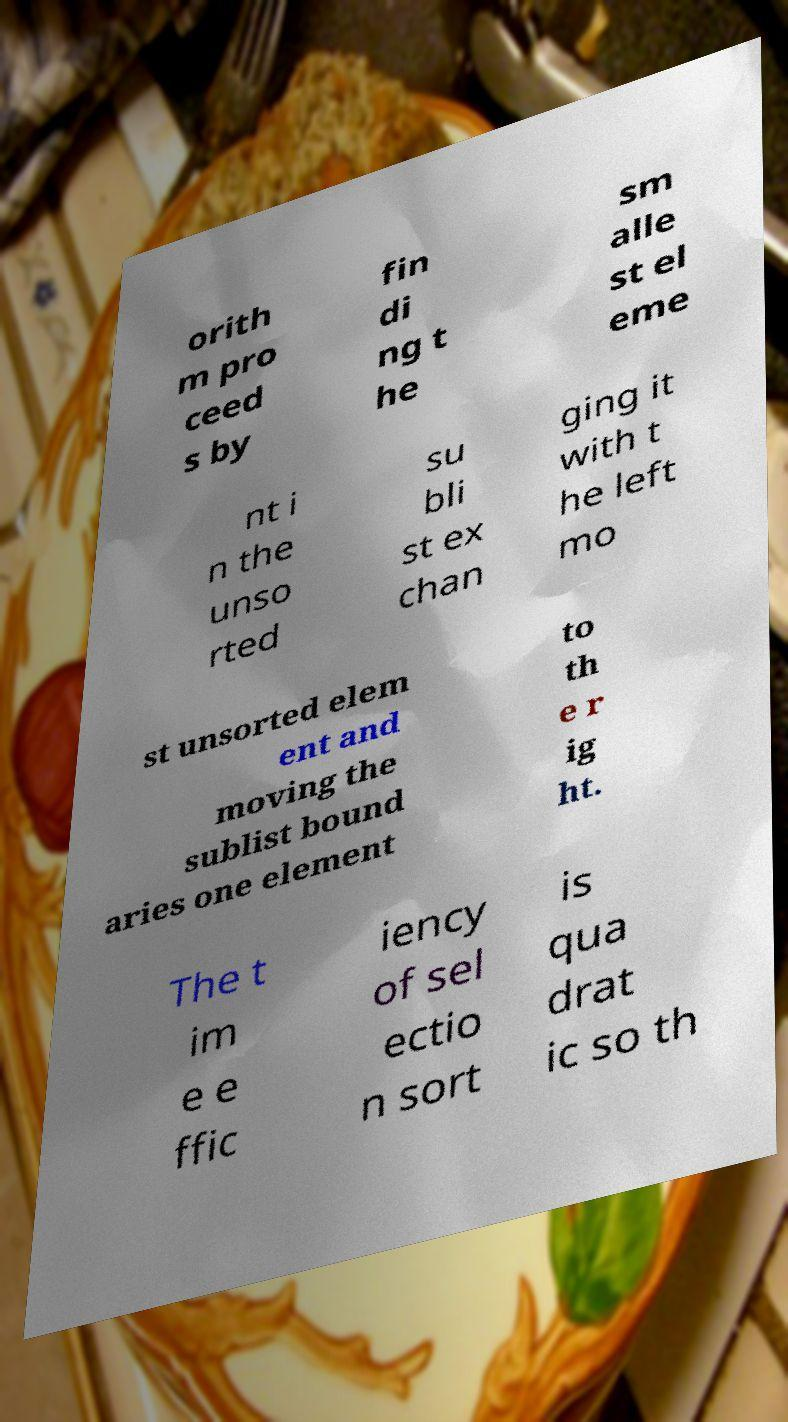There's text embedded in this image that I need extracted. Can you transcribe it verbatim? orith m pro ceed s by fin di ng t he sm alle st el eme nt i n the unso rted su bli st ex chan ging it with t he left mo st unsorted elem ent and moving the sublist bound aries one element to th e r ig ht. The t im e e ffic iency of sel ectio n sort is qua drat ic so th 